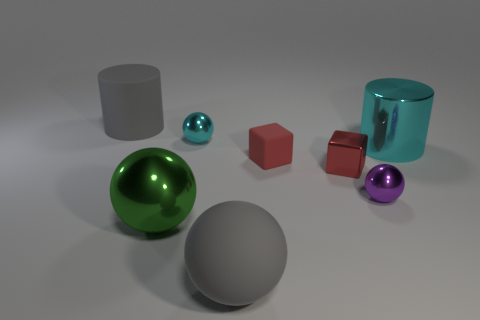Subtract all cyan spheres. How many spheres are left? 3 Subtract all metallic spheres. How many spheres are left? 1 Subtract all yellow spheres. Subtract all purple cylinders. How many spheres are left? 4 Add 1 small cyan metal balls. How many objects exist? 9 Subtract all cylinders. How many objects are left? 6 Subtract all purple balls. Subtract all small red things. How many objects are left? 5 Add 2 blocks. How many blocks are left? 4 Add 7 big gray rubber balls. How many big gray rubber balls exist? 8 Subtract 1 gray balls. How many objects are left? 7 